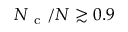Convert formula to latex. <formula><loc_0><loc_0><loc_500><loc_500>N _ { c } / N \gtrsim 0 . 9</formula> 